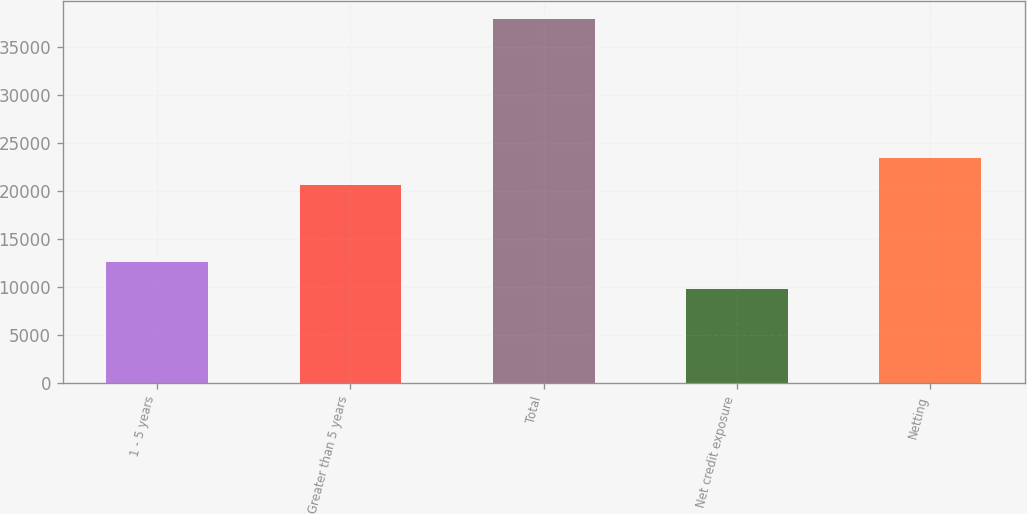Convert chart. <chart><loc_0><loc_0><loc_500><loc_500><bar_chart><fcel>1 - 5 years<fcel>Greater than 5 years<fcel>Total<fcel>Net credit exposure<fcel>Netting<nl><fcel>12638.1<fcel>20687<fcel>37920<fcel>9829<fcel>23496.1<nl></chart> 